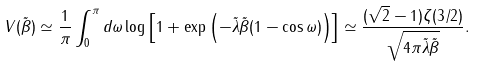Convert formula to latex. <formula><loc_0><loc_0><loc_500><loc_500>V ( \tilde { \beta } ) \simeq \frac { 1 } { \pi } \int _ { 0 } ^ { \pi } d \omega \log \left [ 1 + \exp \left ( - \tilde { \lambda } \tilde { \beta } ( 1 - \cos \omega ) \right ) \right ] \simeq \frac { ( \sqrt { 2 } - 1 ) \zeta ( 3 / 2 ) } { \sqrt { 4 \pi \tilde { \lambda } \tilde { \beta } } } .</formula> 